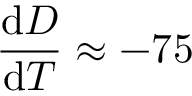<formula> <loc_0><loc_0><loc_500><loc_500>\frac { d D } { d T } \approx - 7 5</formula> 